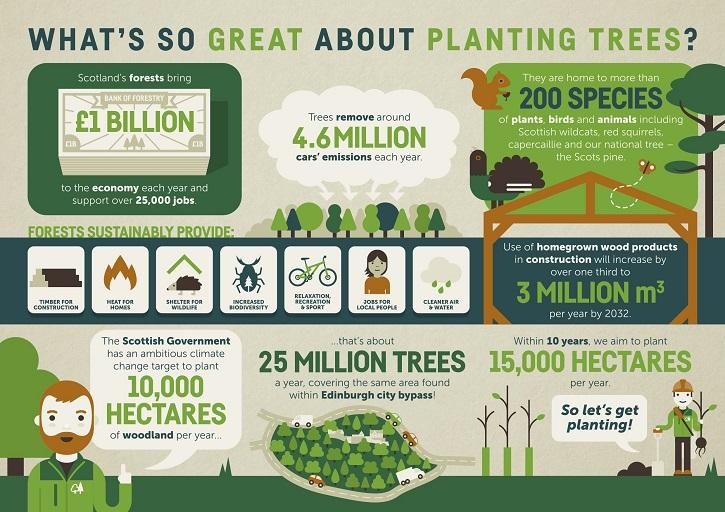Mention a couple of crucial points in this snapshot. The forestry industry's economic contribution to Scotland each year is estimated to be £1 billion. 